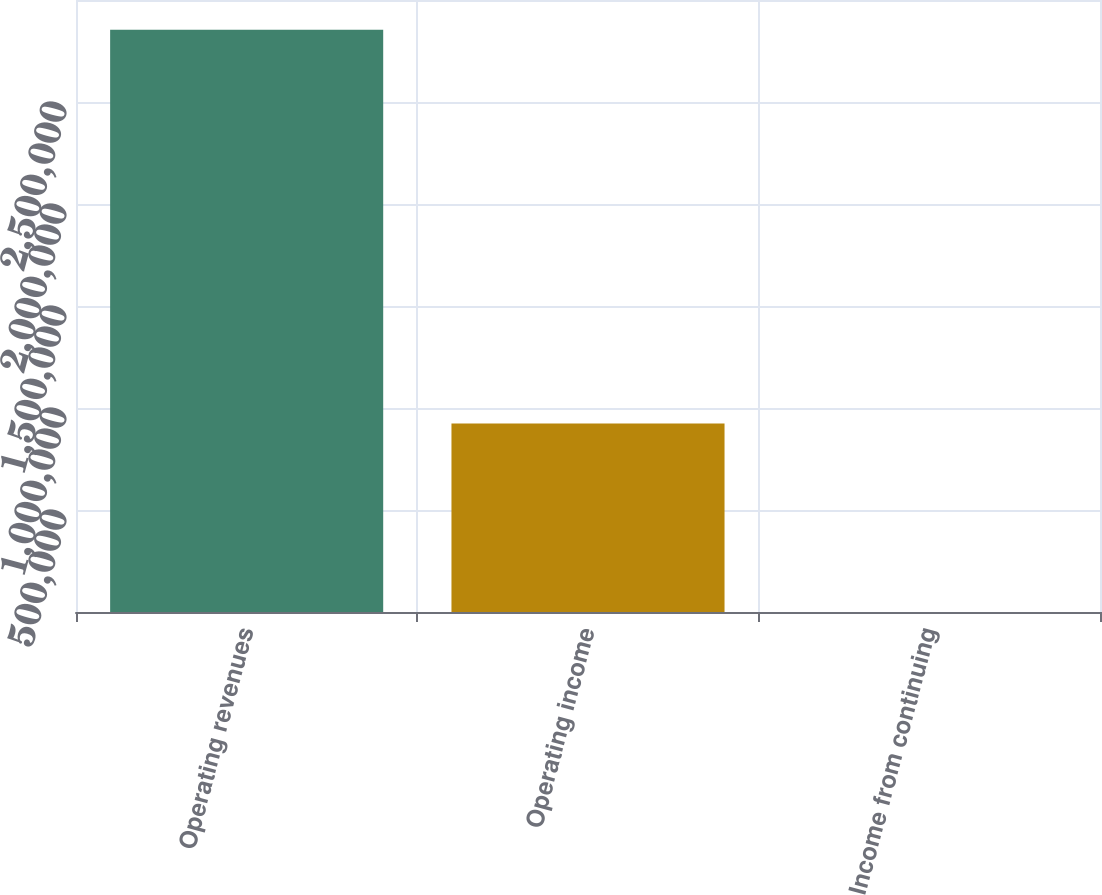Convert chart. <chart><loc_0><loc_0><loc_500><loc_500><bar_chart><fcel>Operating revenues<fcel>Operating income<fcel>Income from continuing<nl><fcel>2.85393e+06<fcel>924104<fcel>2.1<nl></chart> 